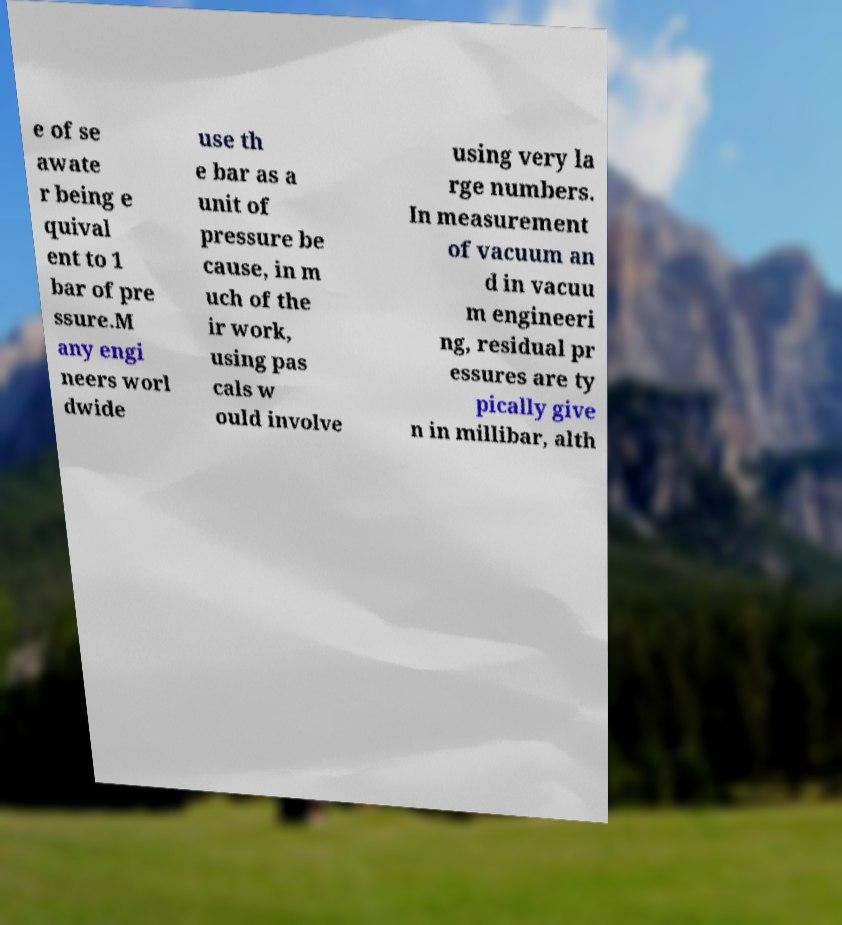Could you extract and type out the text from this image? e of se awate r being e quival ent to 1 bar of pre ssure.M any engi neers worl dwide use th e bar as a unit of pressure be cause, in m uch of the ir work, using pas cals w ould involve using very la rge numbers. In measurement of vacuum an d in vacuu m engineeri ng, residual pr essures are ty pically give n in millibar, alth 